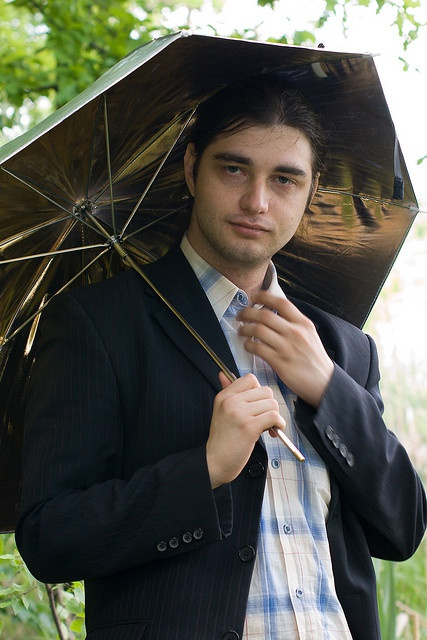Describe the objects in this image and their specific colors. I can see people in khaki, black, gray, lightgray, and darkgray tones and umbrella in khaki, black, olive, and gray tones in this image. 